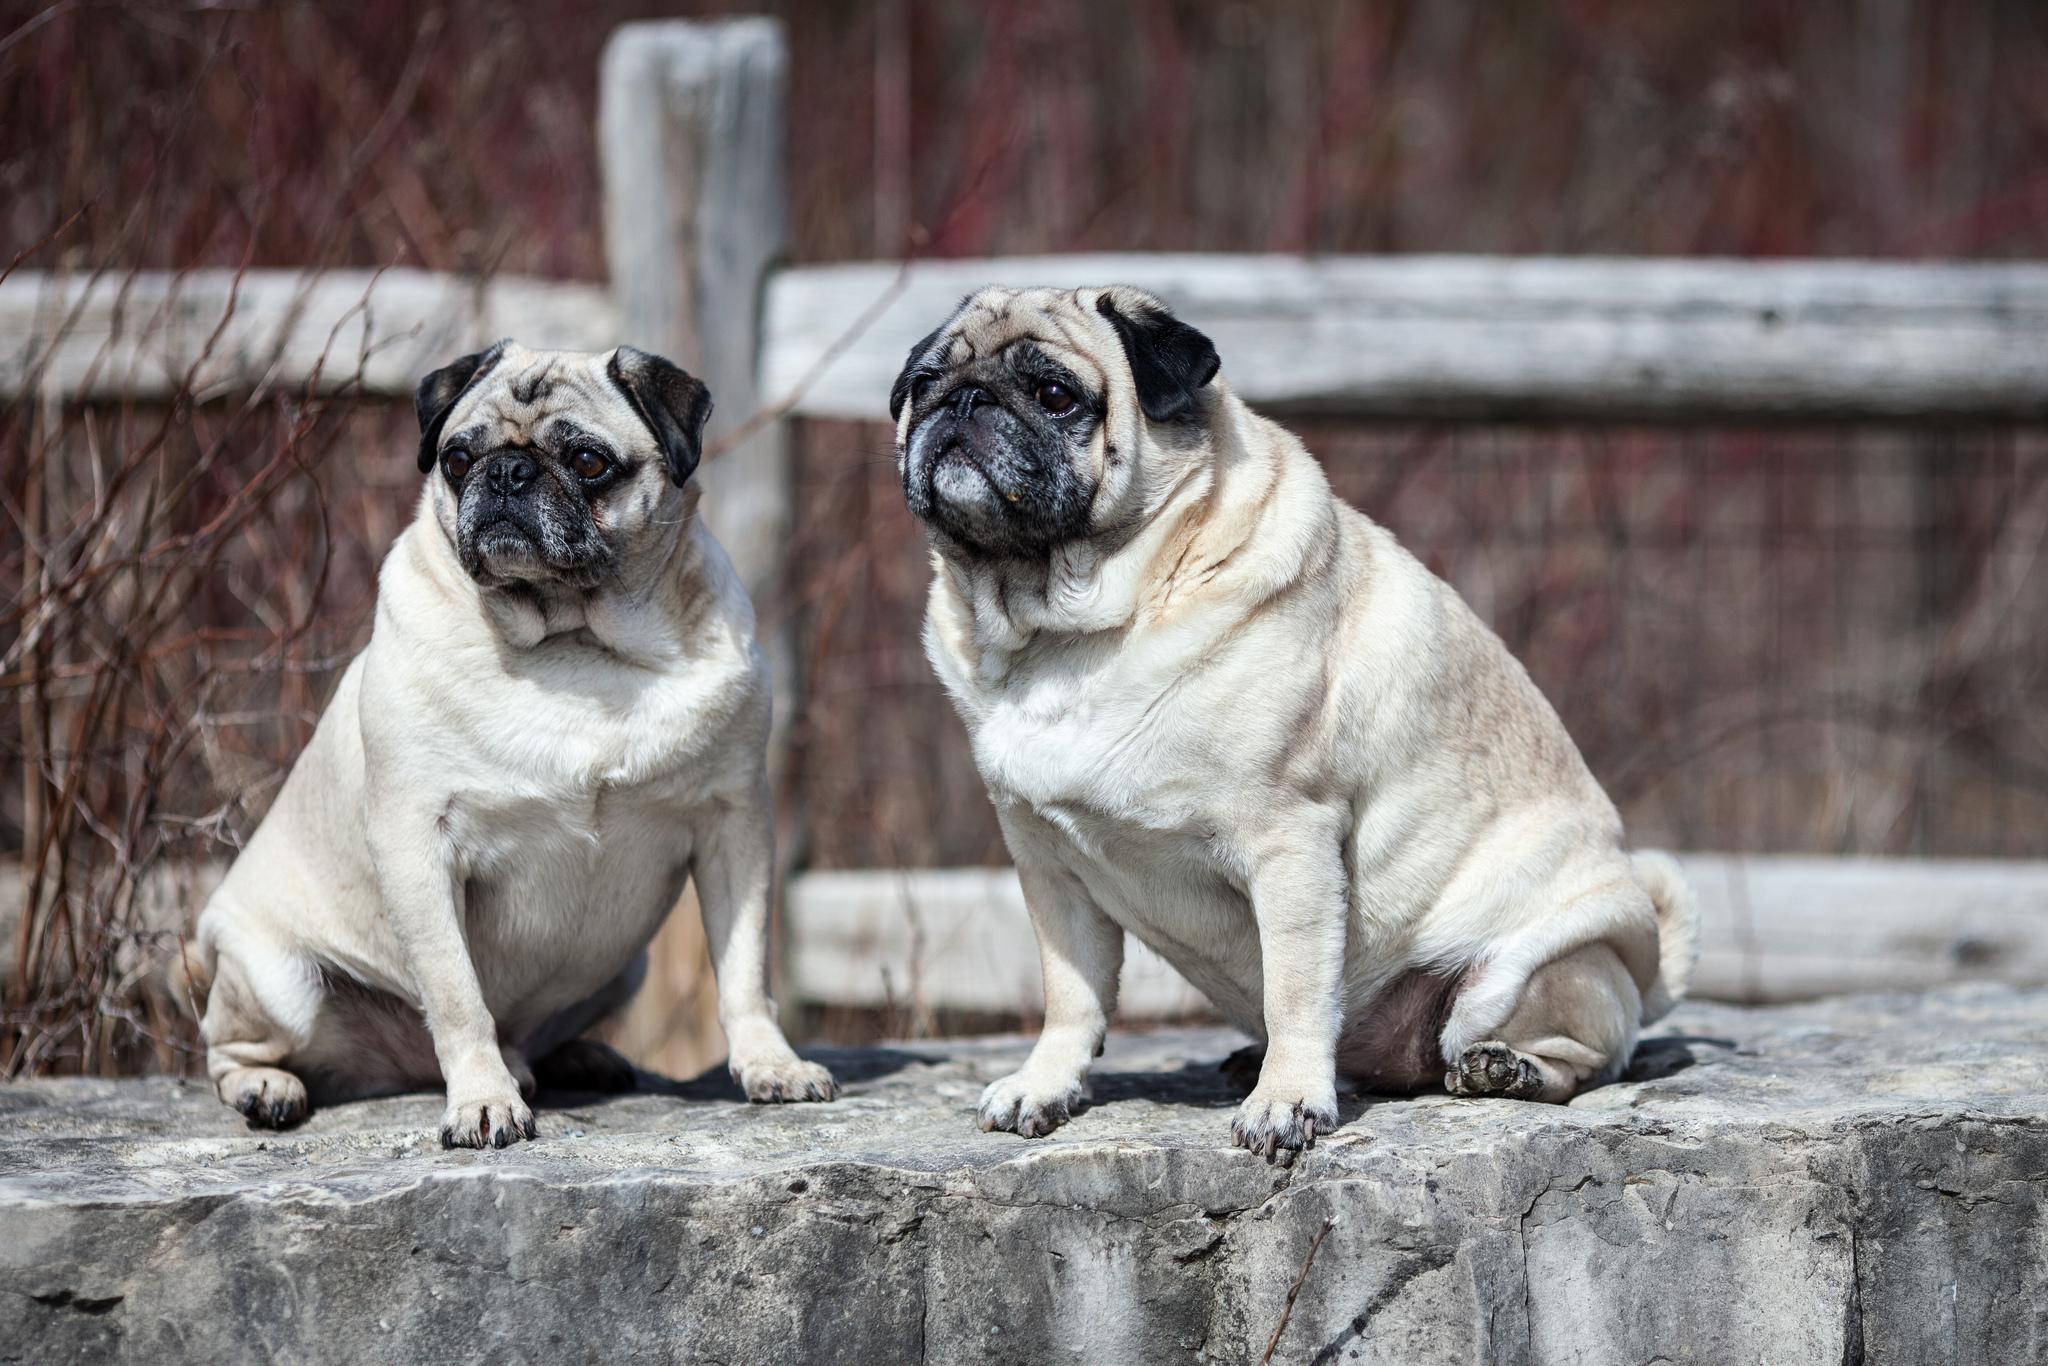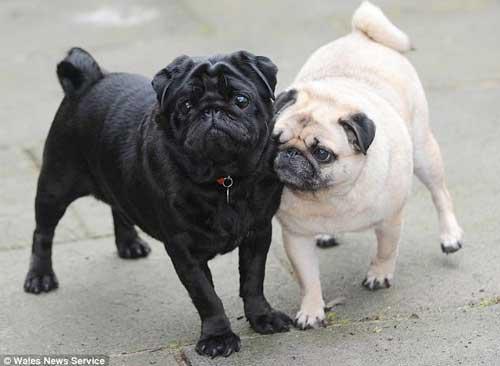The first image is the image on the left, the second image is the image on the right. Analyze the images presented: Is the assertion "One of the pugs shown is black, and the rest are light tan with dark faces." valid? Answer yes or no. Yes. The first image is the image on the left, the second image is the image on the right. Evaluate the accuracy of this statement regarding the images: "There are four dogs.". Is it true? Answer yes or no. Yes. 